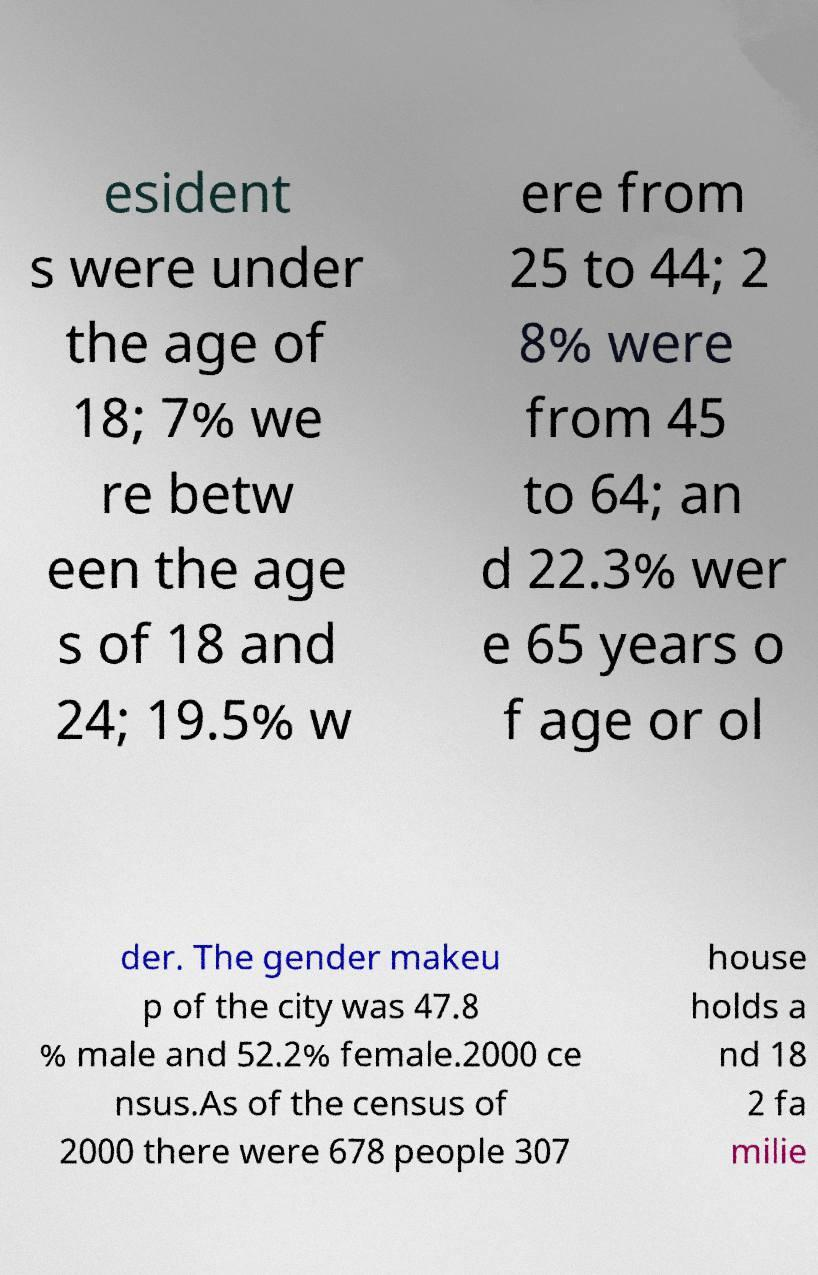Can you read and provide the text displayed in the image?This photo seems to have some interesting text. Can you extract and type it out for me? esident s were under the age of 18; 7% we re betw een the age s of 18 and 24; 19.5% w ere from 25 to 44; 2 8% were from 45 to 64; an d 22.3% wer e 65 years o f age or ol der. The gender makeu p of the city was 47.8 % male and 52.2% female.2000 ce nsus.As of the census of 2000 there were 678 people 307 house holds a nd 18 2 fa milie 